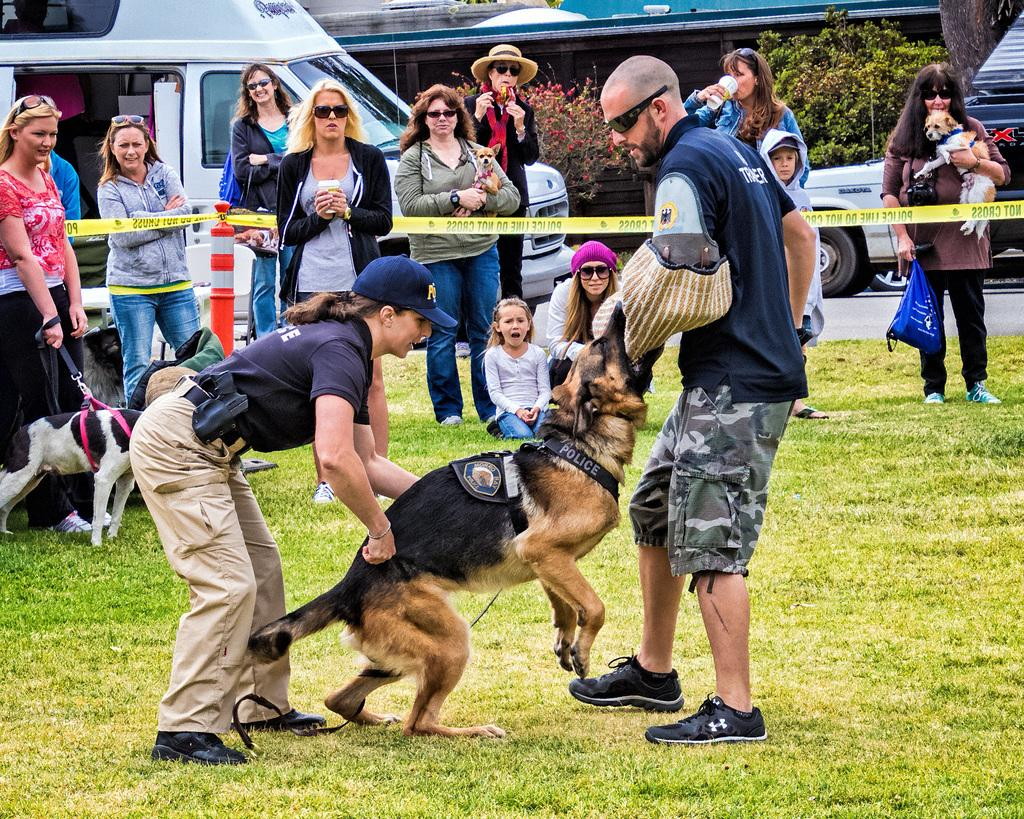What is the main subject of the image? The main subject of the image is a group of people standing. Are there any animals present in the image? Yes, there is a dog in brown and black colors in the image. What can be seen in the background of the image? Vehicles are visible in the background of the image. What is the color of the trees in the background? The trees in the background are green. What type of agreement is being signed by the people in the image? There is no indication in the image that the people are signing any agreement. --- Facts: 1. There is a person sitting on a chair in the image. 2. The person is holding a book. 3. There is a table next to the chair. 4. The table has a lamp on it. 5. The room has a window. Absurd Topics: parrot, ocean, bicycle Conversation: What is the person in the image doing? The person in the image is sitting on a chair. What object is the person holding? The person is holding a book. What is located next to the chair? There is a table next to the chair. What is on the table? The table has a lamp on it. What feature of the room can be seen in the image? The room has a window. Reasoning: Let's think step by step in order to produce the conversation. We start by identifying the main subject of the image, which is the person sitting on a chair. Then, we mention the object the person is holding, which is a book. Next, we focus on the furniture and objects in the room, noting the presence of a table and a lamp. Finally, we mention a feature of the room, which is the window. Each question is designed to elicit a specific detail about the image that is known from the provided facts. Absurd Question/Answer: Can you see a parrot flying near the window in the image? There is no parrot visible in the image. 